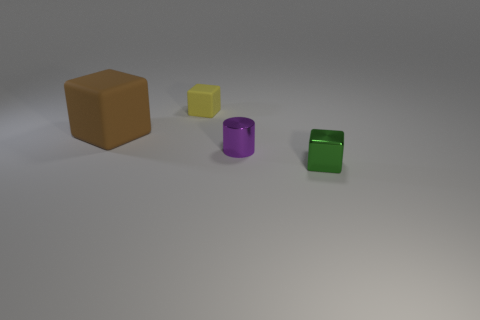Can you tell me the colors of the small objects? Certainly! There are three small objects, each with a distinct color: yellow, purple, and green. 